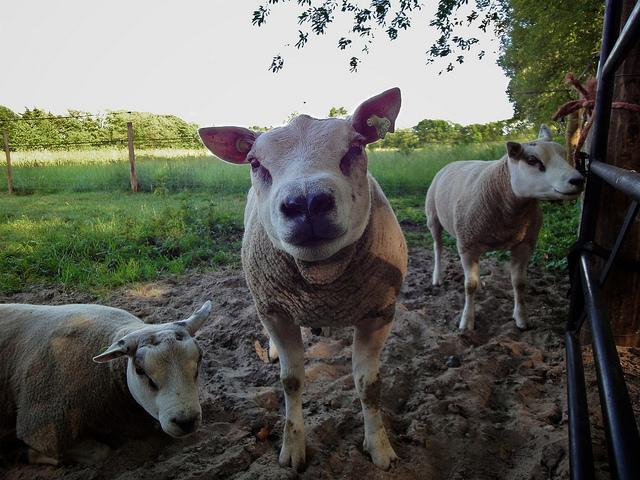How many weird looking sheeps are standing on top of the dirt pile? Please explain your reasoning. three. One is laying down out of the three 